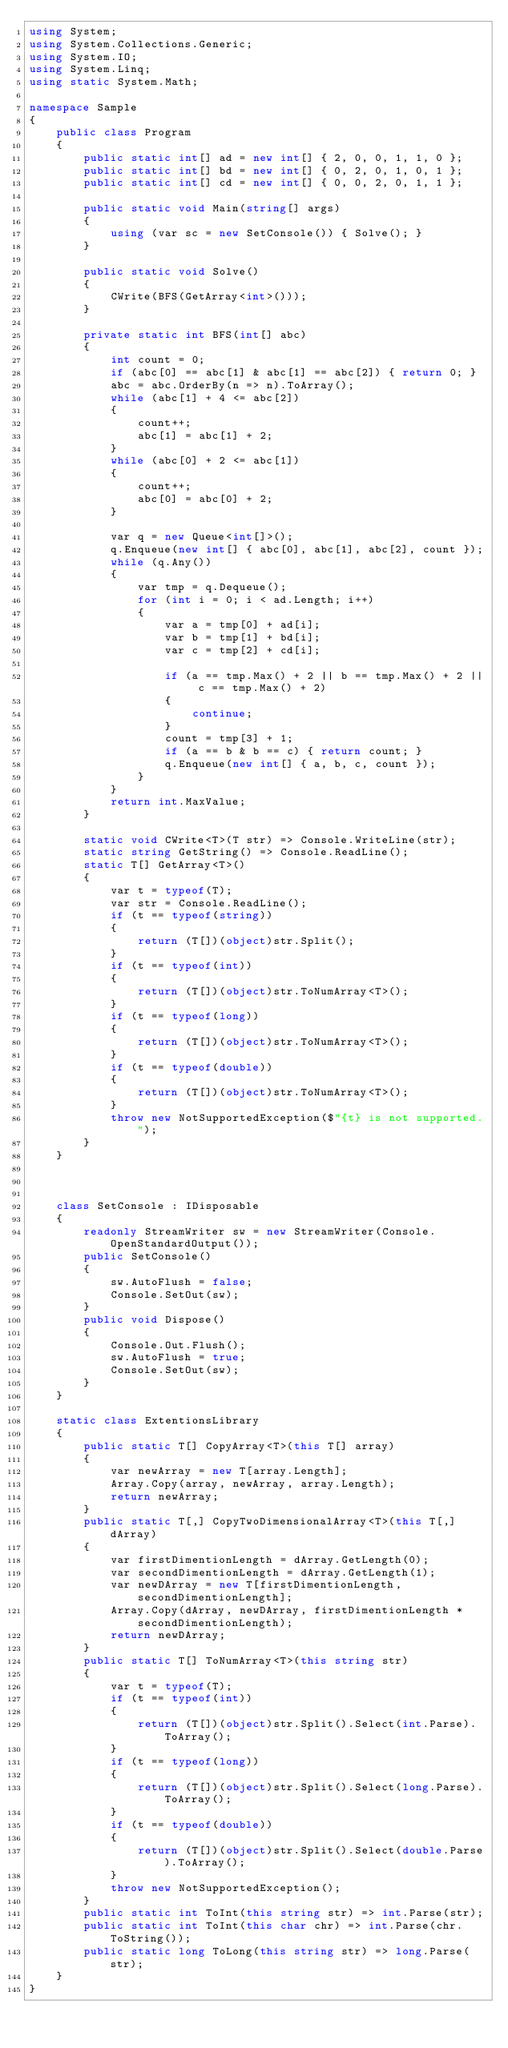<code> <loc_0><loc_0><loc_500><loc_500><_C#_>using System;
using System.Collections.Generic;
using System.IO;
using System.Linq;
using static System.Math;

namespace Sample
{
    public class Program
    {
        public static int[] ad = new int[] { 2, 0, 0, 1, 1, 0 };
        public static int[] bd = new int[] { 0, 2, 0, 1, 0, 1 };
        public static int[] cd = new int[] { 0, 0, 2, 0, 1, 1 };

        public static void Main(string[] args)
        {
            using (var sc = new SetConsole()) { Solve(); }
        }

        public static void Solve()
        {
            CWrite(BFS(GetArray<int>()));
        }

        private static int BFS(int[] abc)
        {
            int count = 0;
            if (abc[0] == abc[1] & abc[1] == abc[2]) { return 0; }
            abc = abc.OrderBy(n => n).ToArray();
            while (abc[1] + 4 <= abc[2])
            {
                count++;
                abc[1] = abc[1] + 2;
            }
            while (abc[0] + 2 <= abc[1])
            {
                count++;
                abc[0] = abc[0] + 2;
            }
            
            var q = new Queue<int[]>();
            q.Enqueue(new int[] { abc[0], abc[1], abc[2], count });
            while (q.Any())
            {
                var tmp = q.Dequeue();
                for (int i = 0; i < ad.Length; i++)
                {
                    var a = tmp[0] + ad[i];
                    var b = tmp[1] + bd[i];
                    var c = tmp[2] + cd[i];
                  
                    if (a == tmp.Max() + 2 || b == tmp.Max() + 2 || c == tmp.Max() + 2)
                    {
                        continue;
                    }
                    count = tmp[3] + 1;
                    if (a == b & b == c) { return count; }
                    q.Enqueue(new int[] { a, b, c, count });
                }
            }
            return int.MaxValue;
        }

        static void CWrite<T>(T str) => Console.WriteLine(str);
        static string GetString() => Console.ReadLine();
        static T[] GetArray<T>()
        {
            var t = typeof(T);
            var str = Console.ReadLine();
            if (t == typeof(string))
            {
                return (T[])(object)str.Split();
            }
            if (t == typeof(int))
            {
                return (T[])(object)str.ToNumArray<T>();
            }
            if (t == typeof(long))
            {
                return (T[])(object)str.ToNumArray<T>();
            }
            if (t == typeof(double))
            {
                return (T[])(object)str.ToNumArray<T>();
            }
            throw new NotSupportedException($"{t} is not supported.");
        }
    }



    class SetConsole : IDisposable
    {
        readonly StreamWriter sw = new StreamWriter(Console.OpenStandardOutput());
        public SetConsole()
        {
            sw.AutoFlush = false;
            Console.SetOut(sw);
        }
        public void Dispose()
        {
            Console.Out.Flush();
            sw.AutoFlush = true;
            Console.SetOut(sw);
        }
    }

    static class ExtentionsLibrary
    {
        public static T[] CopyArray<T>(this T[] array)
        {
            var newArray = new T[array.Length];
            Array.Copy(array, newArray, array.Length);
            return newArray;
        }
        public static T[,] CopyTwoDimensionalArray<T>(this T[,] dArray)
        {
            var firstDimentionLength = dArray.GetLength(0);
            var secondDimentionLength = dArray.GetLength(1);
            var newDArray = new T[firstDimentionLength, secondDimentionLength];
            Array.Copy(dArray, newDArray, firstDimentionLength * secondDimentionLength);
            return newDArray;
        }
        public static T[] ToNumArray<T>(this string str)
        {
            var t = typeof(T);
            if (t == typeof(int))
            {
                return (T[])(object)str.Split().Select(int.Parse).ToArray();
            }
            if (t == typeof(long))
            {
                return (T[])(object)str.Split().Select(long.Parse).ToArray();
            }
            if (t == typeof(double))
            {
                return (T[])(object)str.Split().Select(double.Parse).ToArray();
            }
            throw new NotSupportedException();
        }
        public static int ToInt(this string str) => int.Parse(str);
        public static int ToInt(this char chr) => int.Parse(chr.ToString());
        public static long ToLong(this string str) => long.Parse(str);
    }
}
</code> 